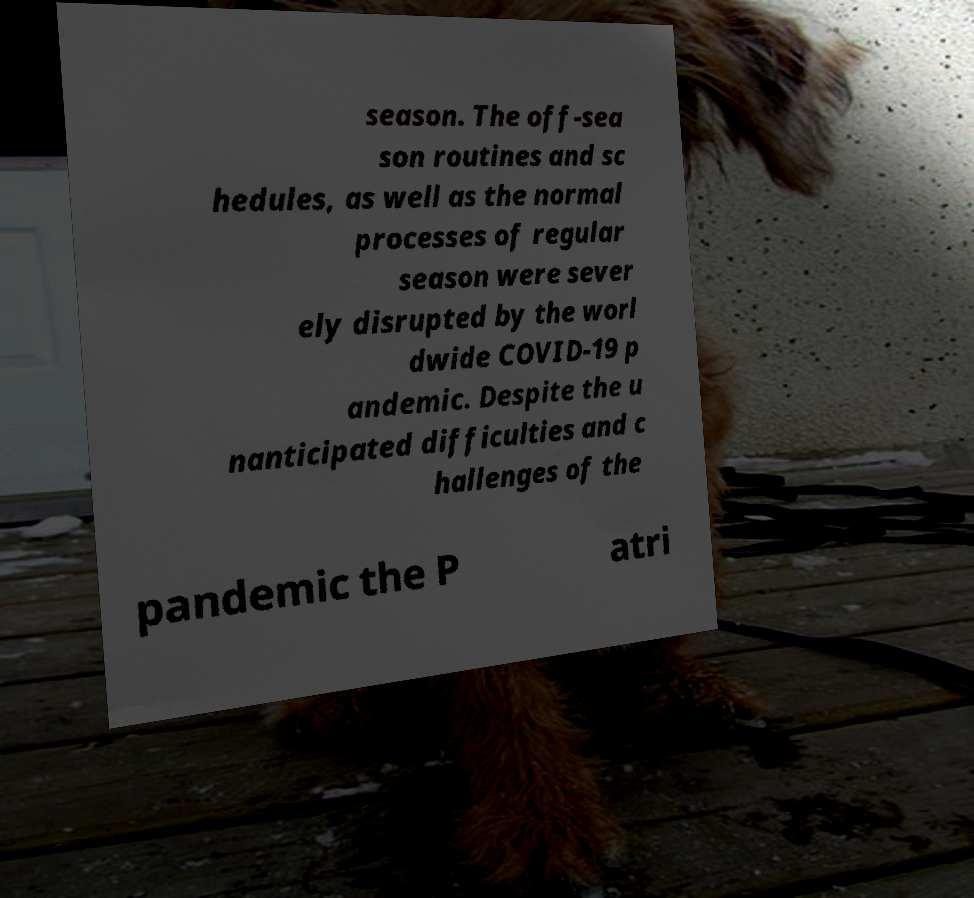Could you extract and type out the text from this image? season. The off-sea son routines and sc hedules, as well as the normal processes of regular season were sever ely disrupted by the worl dwide COVID-19 p andemic. Despite the u nanticipated difficulties and c hallenges of the pandemic the P atri 